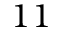<formula> <loc_0><loc_0><loc_500><loc_500>1 1</formula> 